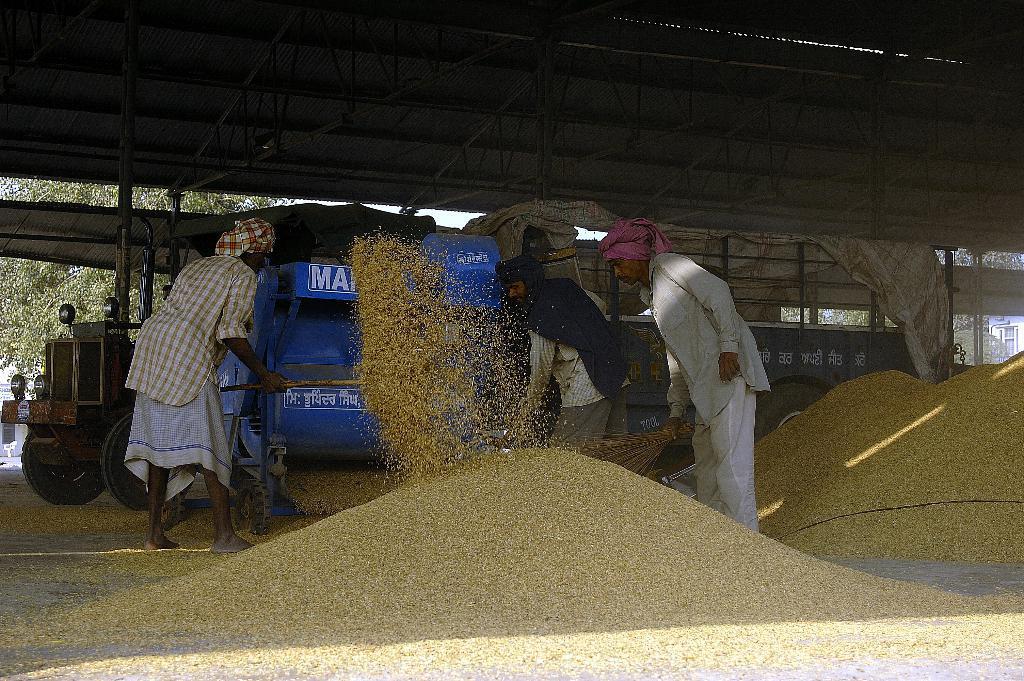Please provide a concise description of this image. In this picture there are people and we can see grains, vehicle, machine and sheds. In the background of the image we can see trees and sky. 